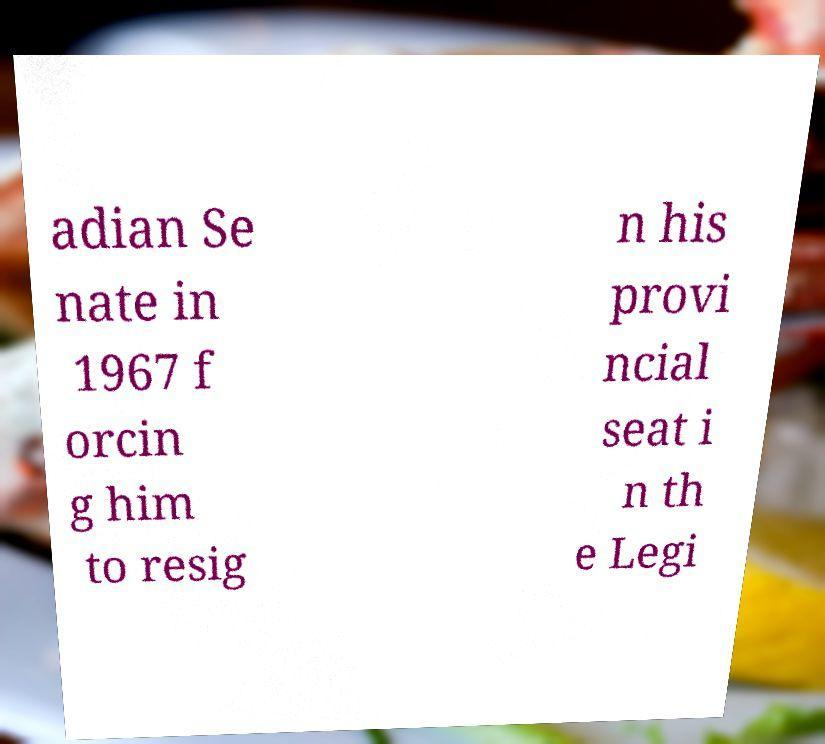For documentation purposes, I need the text within this image transcribed. Could you provide that? adian Se nate in 1967 f orcin g him to resig n his provi ncial seat i n th e Legi 